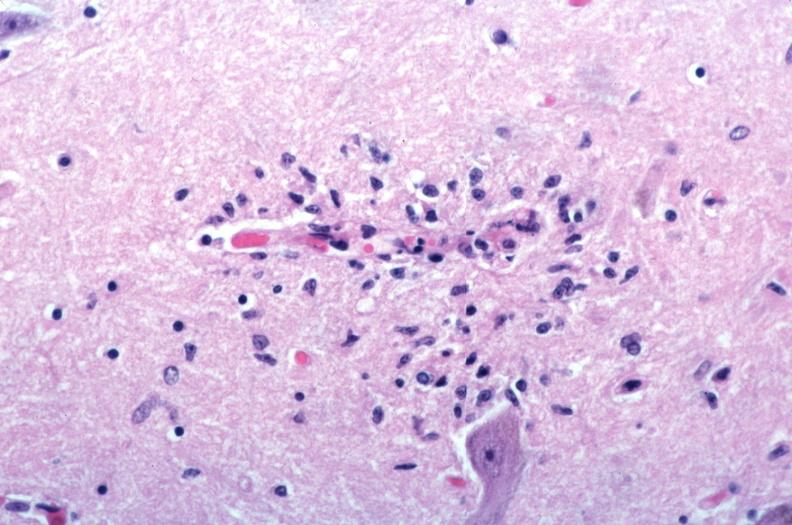what spotted fever?
Answer the question using a single word or phrase. Vasculitis due to rocky mountain 